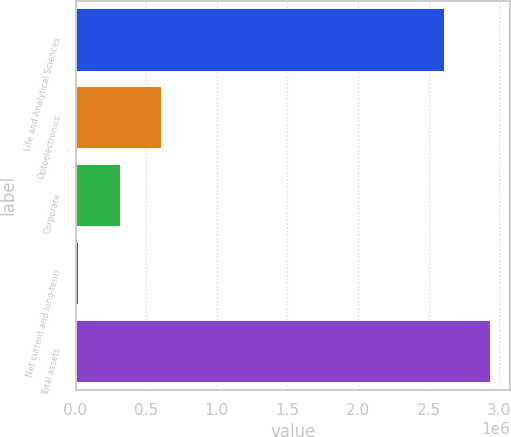Convert chart. <chart><loc_0><loc_0><loc_500><loc_500><bar_chart><fcel>Life and Analytical Sciences<fcel>Optoelectronics<fcel>Corporate<fcel>Net current and long-term<fcel>Total assets<nl><fcel>2.60873e+06<fcel>602809<fcel>311689<fcel>20569<fcel>2.93177e+06<nl></chart> 